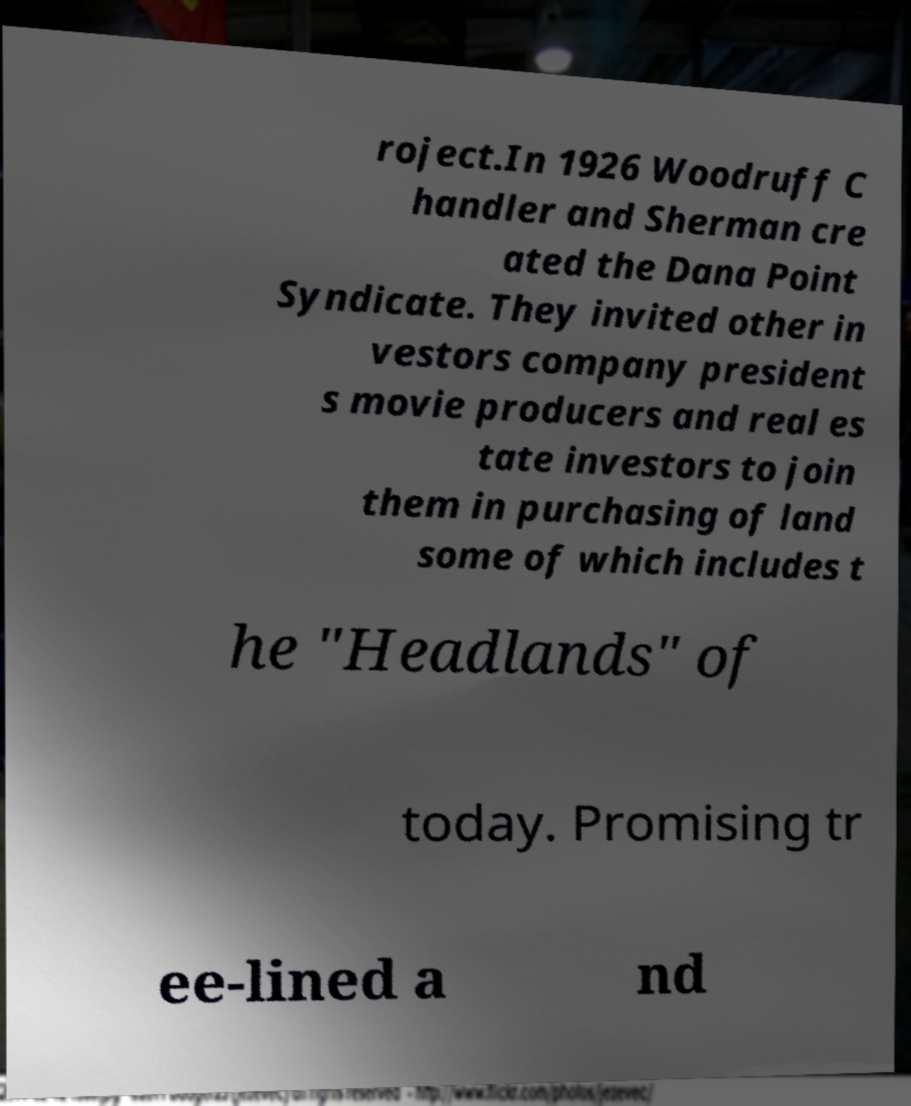Can you accurately transcribe the text from the provided image for me? roject.In 1926 Woodruff C handler and Sherman cre ated the Dana Point Syndicate. They invited other in vestors company president s movie producers and real es tate investors to join them in purchasing of land some of which includes t he "Headlands" of today. Promising tr ee-lined a nd 